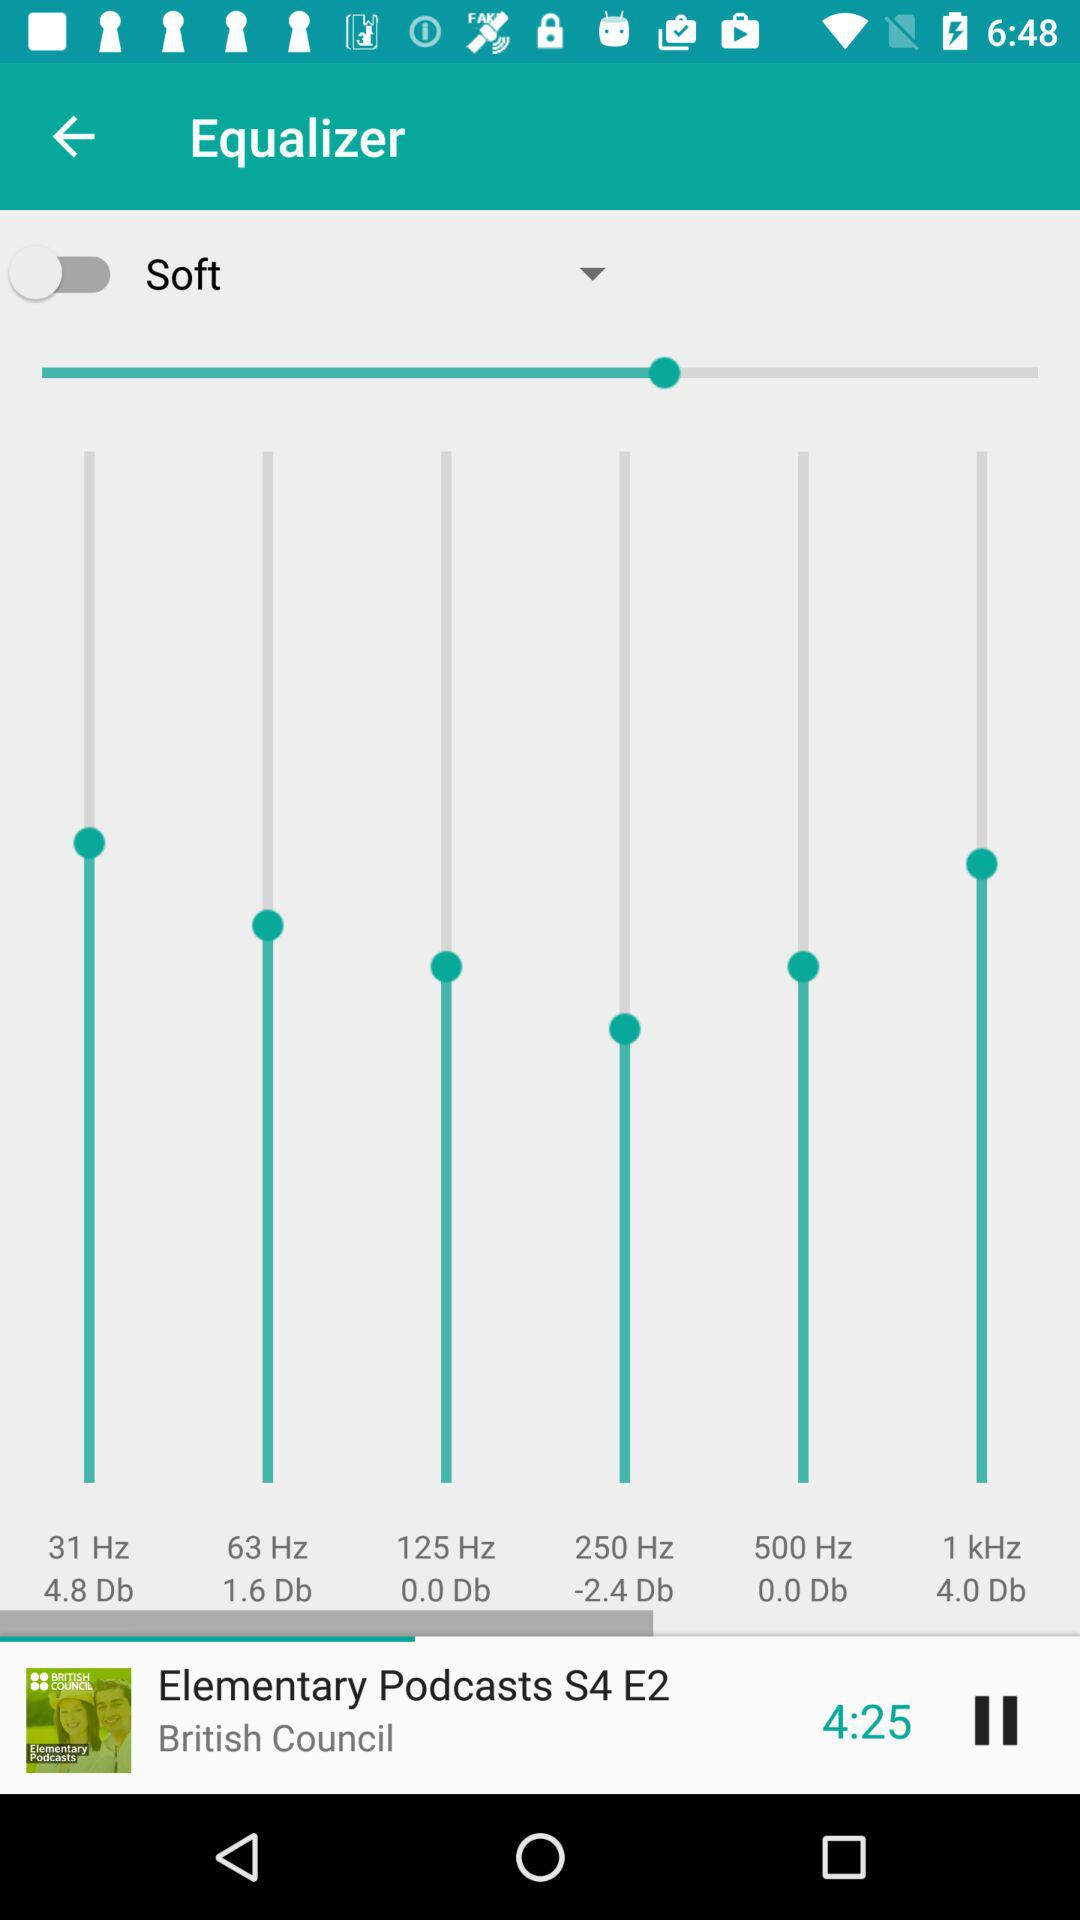How many decibels is the difference between the 125 Hz and 250 Hz frequencies?
Answer the question using a single word or phrase. 2.4 